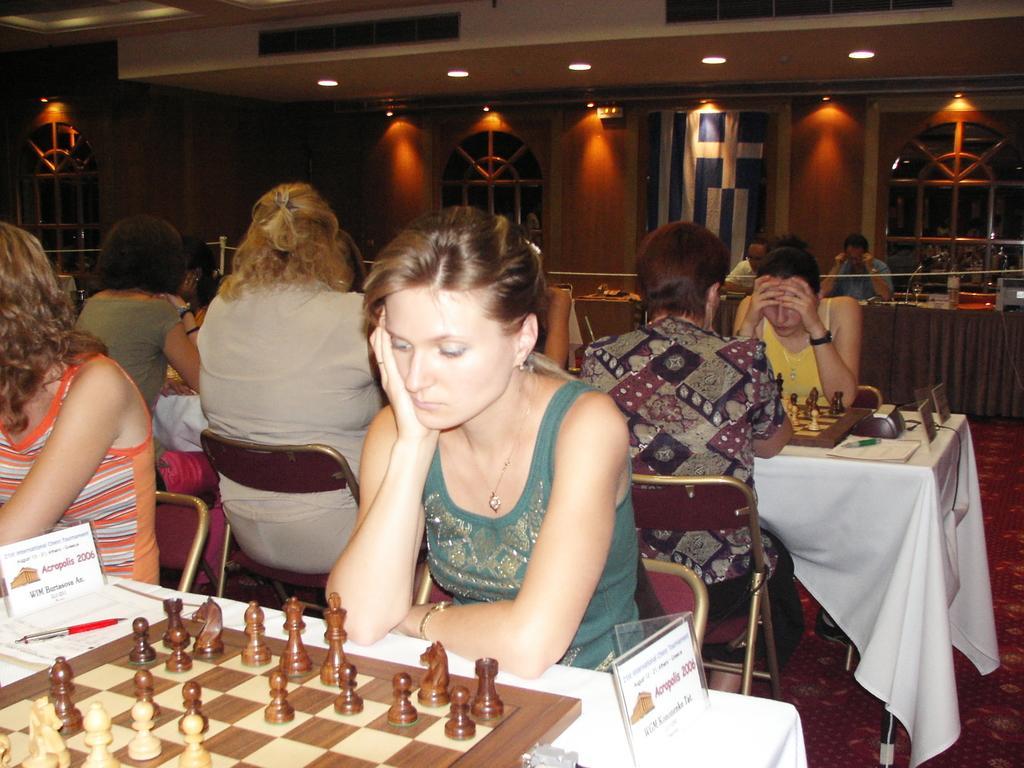How would you summarize this image in a sentence or two? In the image we can see few persons were sitting on the chair around the table. On table there is a chess board,pen and paper. In the background we can see wall,door,light and few more persons were sitting on the chair around the table. 